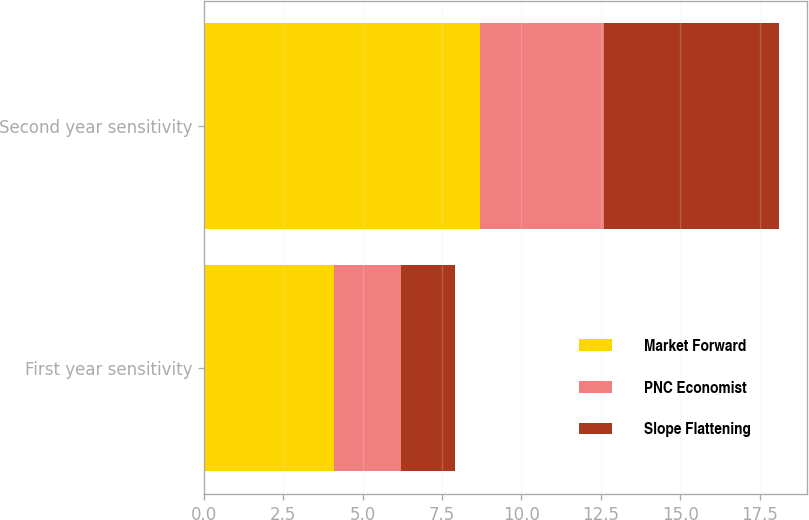<chart> <loc_0><loc_0><loc_500><loc_500><stacked_bar_chart><ecel><fcel>First year sensitivity<fcel>Second year sensitivity<nl><fcel>Market Forward<fcel>4.1<fcel>8.7<nl><fcel>PNC Economist<fcel>2.1<fcel>3.9<nl><fcel>Slope Flattening<fcel>1.7<fcel>5.5<nl></chart> 